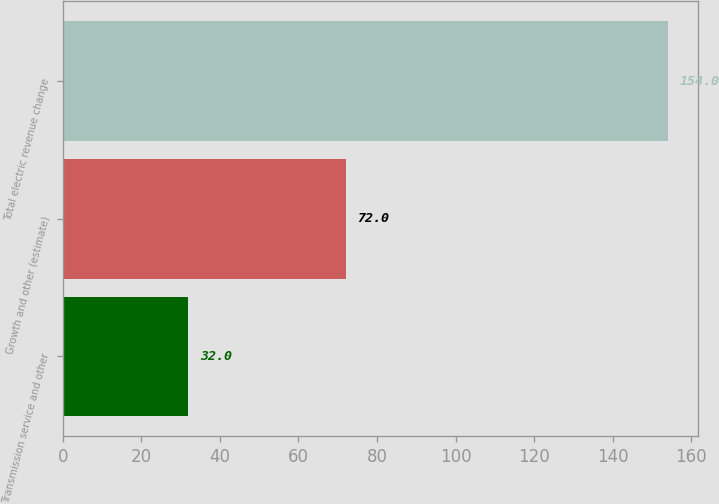Convert chart to OTSL. <chart><loc_0><loc_0><loc_500><loc_500><bar_chart><fcel>Transmission service and other<fcel>Growth and other (estimate)<fcel>Total electric revenue change<nl><fcel>32<fcel>72<fcel>154<nl></chart> 